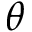Convert formula to latex. <formula><loc_0><loc_0><loc_500><loc_500>\theta</formula> 